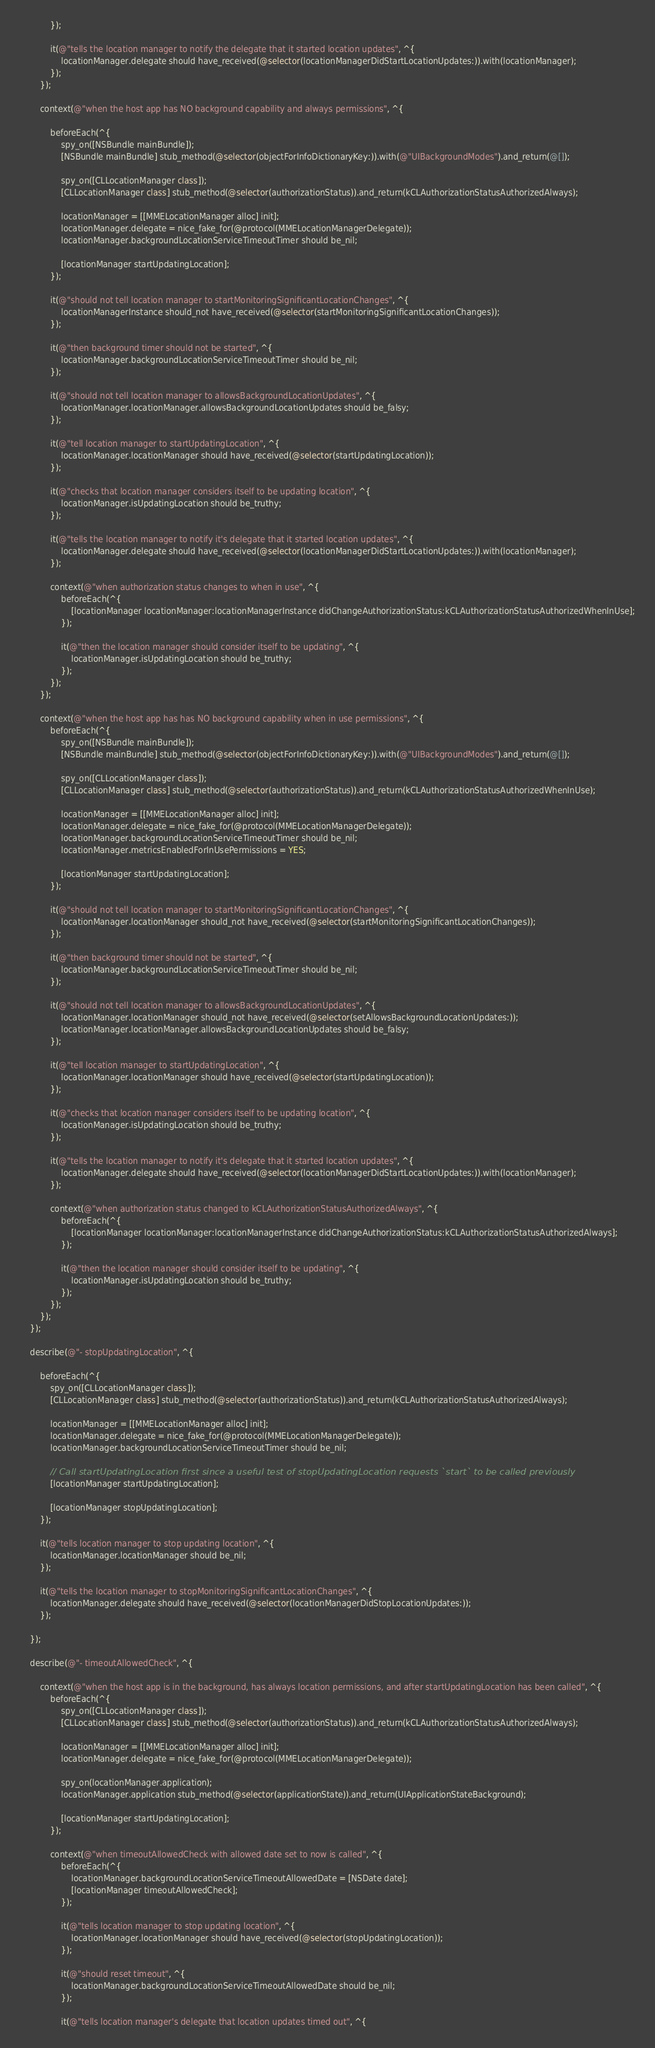<code> <loc_0><loc_0><loc_500><loc_500><_ObjectiveC_>            });
            
            it(@"tells the location manager to notify the delegate that it started location updates", ^{
                locationManager.delegate should have_received(@selector(locationManagerDidStartLocationUpdates:)).with(locationManager);
            });
        });
        
        context(@"when the host app has NO background capability and always permissions", ^{
            
            beforeEach(^{
                spy_on([NSBundle mainBundle]);
                [NSBundle mainBundle] stub_method(@selector(objectForInfoDictionaryKey:)).with(@"UIBackgroundModes").and_return(@[]);
                
                spy_on([CLLocationManager class]);
                [CLLocationManager class] stub_method(@selector(authorizationStatus)).and_return(kCLAuthorizationStatusAuthorizedAlways);
                
                locationManager = [[MMELocationManager alloc] init];
                locationManager.delegate = nice_fake_for(@protocol(MMELocationManagerDelegate));
                locationManager.backgroundLocationServiceTimeoutTimer should be_nil;
                
                [locationManager startUpdatingLocation];
            });
            
            it(@"should not tell location manager to startMonitoringSignificantLocationChanges", ^{
                locationManagerInstance should_not have_received(@selector(startMonitoringSignificantLocationChanges));
            });
            
            it(@"then background timer should not be started", ^{
                locationManager.backgroundLocationServiceTimeoutTimer should be_nil;
            });
            
            it(@"should not tell location manager to allowsBackgroundLocationUpdates", ^{
                locationManager.locationManager.allowsBackgroundLocationUpdates should be_falsy;
            });
            
            it(@"tell location manager to startUpdatingLocation", ^{
                locationManager.locationManager should have_received(@selector(startUpdatingLocation));
            });
            
            it(@"checks that location manager considers itself to be updating location", ^{
                locationManager.isUpdatingLocation should be_truthy;
            });
            
            it(@"tells the location manager to notify it's delegate that it started location updates", ^{
                locationManager.delegate should have_received(@selector(locationManagerDidStartLocationUpdates:)).with(locationManager);
            });
            
            context(@"when authorization status changes to when in use", ^{
                beforeEach(^{
                    [locationManager locationManager:locationManagerInstance didChangeAuthorizationStatus:kCLAuthorizationStatusAuthorizedWhenInUse];
                });
                
                it(@"then the location manager should consider itself to be updating", ^{
                    locationManager.isUpdatingLocation should be_truthy;
                });
            });
        });
        
        context(@"when the host app has has NO background capability when in use permissions", ^{
            beforeEach(^{
                spy_on([NSBundle mainBundle]);
                [NSBundle mainBundle] stub_method(@selector(objectForInfoDictionaryKey:)).with(@"UIBackgroundModes").and_return(@[]);
                
                spy_on([CLLocationManager class]);
                [CLLocationManager class] stub_method(@selector(authorizationStatus)).and_return(kCLAuthorizationStatusAuthorizedWhenInUse);
                
                locationManager = [[MMELocationManager alloc] init];
                locationManager.delegate = nice_fake_for(@protocol(MMELocationManagerDelegate));
                locationManager.backgroundLocationServiceTimeoutTimer should be_nil;
                locationManager.metricsEnabledForInUsePermissions = YES;
                
                [locationManager startUpdatingLocation];
            });
            
            it(@"should not tell location manager to startMonitoringSignificantLocationChanges", ^{
                locationManager.locationManager should_not have_received(@selector(startMonitoringSignificantLocationChanges));
            });
            
            it(@"then background timer should not be started", ^{
                locationManager.backgroundLocationServiceTimeoutTimer should be_nil;
            });
            
            it(@"should not tell location manager to allowsBackgroundLocationUpdates", ^{
                locationManager.locationManager should_not have_received(@selector(setAllowsBackgroundLocationUpdates:));
                locationManager.locationManager.allowsBackgroundLocationUpdates should be_falsy;
            });
            
            it(@"tell location manager to startUpdatingLocation", ^{
                locationManager.locationManager should have_received(@selector(startUpdatingLocation));
            });
            
            it(@"checks that location manager considers itself to be updating location", ^{
                locationManager.isUpdatingLocation should be_truthy;
            });
            
            it(@"tells the location manager to notify it's delegate that it started location updates", ^{
                locationManager.delegate should have_received(@selector(locationManagerDidStartLocationUpdates:)).with(locationManager);
            });
            
            context(@"when authorization status changed to kCLAuthorizationStatusAuthorizedAlways", ^{
                beforeEach(^{
                    [locationManager locationManager:locationManagerInstance didChangeAuthorizationStatus:kCLAuthorizationStatusAuthorizedAlways];
                });
                
                it(@"then the location manager should consider itself to be updating", ^{
                    locationManager.isUpdatingLocation should be_truthy;
                });
            });
        });
    });
    
    describe(@"- stopUpdatingLocation", ^{
        
        beforeEach(^{
            spy_on([CLLocationManager class]);
            [CLLocationManager class] stub_method(@selector(authorizationStatus)).and_return(kCLAuthorizationStatusAuthorizedAlways);
            
            locationManager = [[MMELocationManager alloc] init];
            locationManager.delegate = nice_fake_for(@protocol(MMELocationManagerDelegate));
            locationManager.backgroundLocationServiceTimeoutTimer should be_nil;
            
            // Call startUpdatingLocation first since a useful test of stopUpdatingLocation requests `start` to be called previously
            [locationManager startUpdatingLocation];
            
            [locationManager stopUpdatingLocation];
        });
        
        it(@"tells location manager to stop updating location", ^{
            locationManager.locationManager should be_nil;
        });
        
        it(@"tells the location manager to stopMonitoringSignificantLocationChanges", ^{
            locationManager.delegate should have_received(@selector(locationManagerDidStopLocationUpdates:));
        });
        
    });
    
    describe(@"- timeoutAllowedCheck", ^{
        
        context(@"when the host app is in the background, has always location permissions, and after startUpdatingLocation has been called", ^{
            beforeEach(^{
                spy_on([CLLocationManager class]);
                [CLLocationManager class] stub_method(@selector(authorizationStatus)).and_return(kCLAuthorizationStatusAuthorizedAlways);
                
                locationManager = [[MMELocationManager alloc] init];
                locationManager.delegate = nice_fake_for(@protocol(MMELocationManagerDelegate));
                
                spy_on(locationManager.application);
                locationManager.application stub_method(@selector(applicationState)).and_return(UIApplicationStateBackground);
                
                [locationManager startUpdatingLocation];
            });
            
            context(@"when timeoutAllowedCheck with allowed date set to now is called", ^{
                beforeEach(^{
                    locationManager.backgroundLocationServiceTimeoutAllowedDate = [NSDate date];
                    [locationManager timeoutAllowedCheck];
                });
                
                it(@"tells location manager to stop updating location", ^{
                    locationManager.locationManager should have_received(@selector(stopUpdatingLocation));
                });
                
                it(@"should reset timeout", ^{
                    locationManager.backgroundLocationServiceTimeoutAllowedDate should be_nil;
                });
                
                it(@"tells location manager's delegate that location updates timed out", ^{</code> 